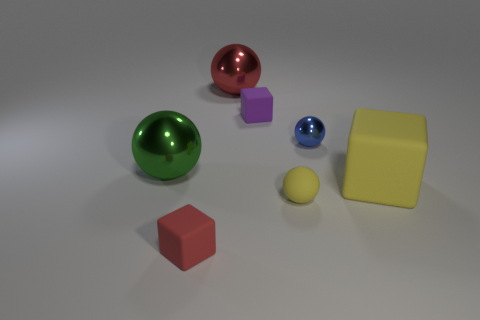What is the shape of the red object that is behind the red object in front of the large yellow rubber block?
Your response must be concise. Sphere. What number of other cubes are the same size as the red cube?
Keep it short and to the point. 1. Is there a big red sphere?
Offer a terse response. Yes. Is there anything else that is the same color as the tiny shiny thing?
Your answer should be very brief. No. What shape is the small thing that is made of the same material as the red ball?
Provide a succinct answer. Sphere. What color is the small ball that is behind the large sphere to the left of the matte cube that is in front of the tiny yellow ball?
Offer a very short reply. Blue. Are there an equal number of blue shiny balls in front of the matte ball and big cyan matte blocks?
Make the answer very short. Yes. Are there any other things that are the same material as the small yellow ball?
Provide a short and direct response. Yes. Do the tiny metallic object and the small thing that is behind the tiny blue shiny sphere have the same color?
Provide a short and direct response. No. There is a small block that is behind the large metallic thing in front of the blue shiny thing; are there any large rubber objects that are behind it?
Keep it short and to the point. No. 